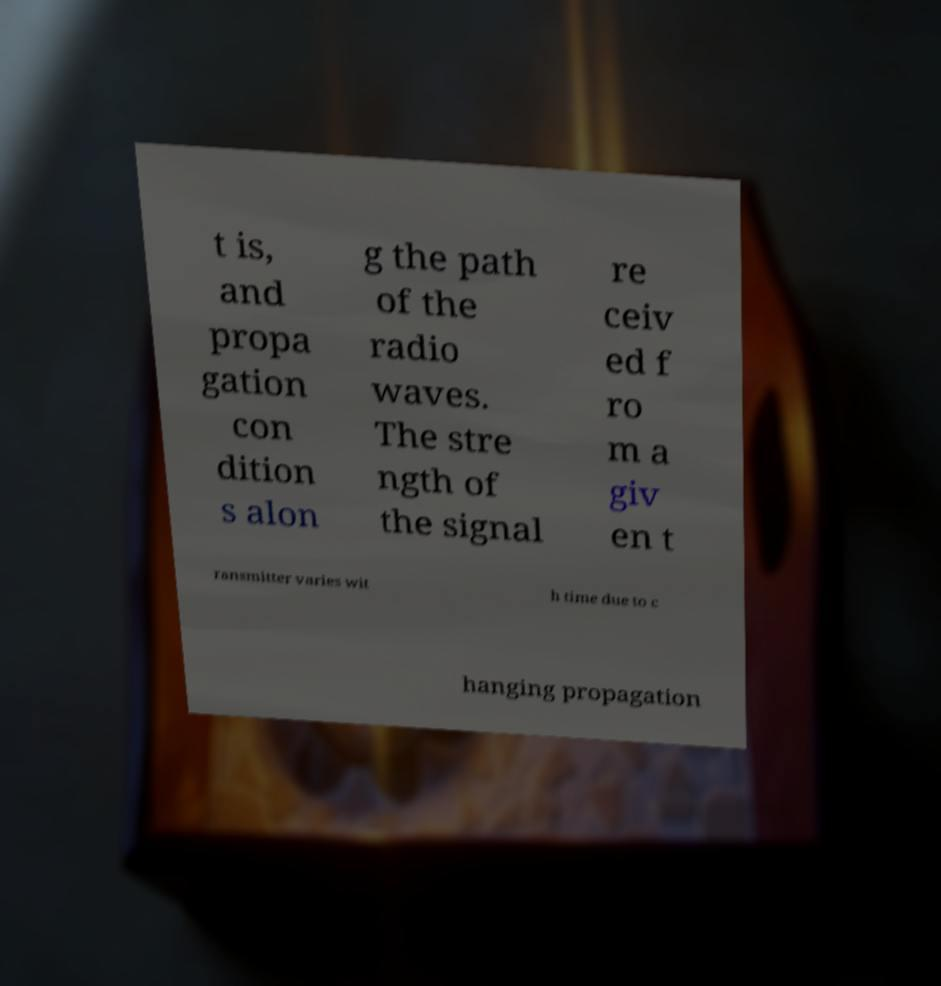Could you extract and type out the text from this image? t is, and propa gation con dition s alon g the path of the radio waves. The stre ngth of the signal re ceiv ed f ro m a giv en t ransmitter varies wit h time due to c hanging propagation 